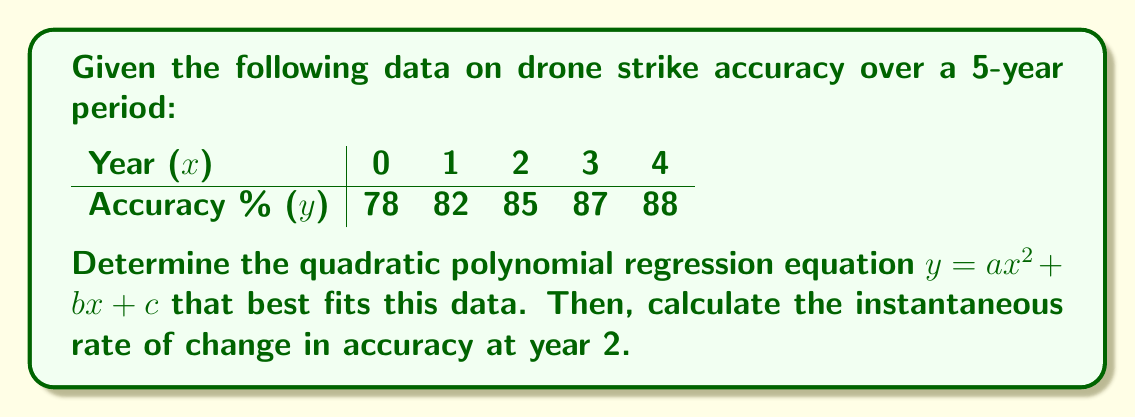Teach me how to tackle this problem. 1) To find the quadratic polynomial regression equation, we need to solve the normal equations:

   $$\begin{cases}
   \sum y = an + b\sum x + c\sum x^2 \\
   \sum xy = a\sum x + b\sum x^2 + c\sum x^3 \\
   \sum x^2y = a\sum x^2 + b\sum x^3 + c\sum x^4
   \end{cases}$$

2) Calculate the required sums:
   $\sum x = 0 + 1 + 2 + 3 + 4 = 10$
   $\sum x^2 = 0 + 1 + 4 + 9 + 16 = 30$
   $\sum x^3 = 0 + 1 + 8 + 27 + 64 = 100$
   $\sum x^4 = 0 + 1 + 16 + 81 + 256 = 354$
   $\sum y = 78 + 82 + 85 + 87 + 88 = 420$
   $\sum xy = 0 + 82 + 170 + 261 + 352 = 865$
   $\sum x^2y = 0 + 82 + 340 + 783 + 1408 = 2613$

3) Substitute these values into the normal equations:

   $$\begin{cases}
   420 = 5a + 10b + 30c \\
   865 = 10a + 30b + 100c \\
   2613 = 30a + 100b + 354c
   \end{cases}$$

4) Solve this system of equations (using a calculator or computer algebra system) to get:
   $a = -0.5$, $b = 5$, $c = 78$

5) Therefore, the quadratic regression equation is:
   $y = -0.5x^2 + 5x + 78$

6) To find the instantaneous rate of change at year 2, we need to calculate the derivative of this function and evaluate it at x = 2:

   $\frac{dy}{dx} = -x + 5$

   At x = 2: $\frac{dy}{dx}|_{x=2} = -2 + 5 = 3$
Answer: $3\%$ per year 